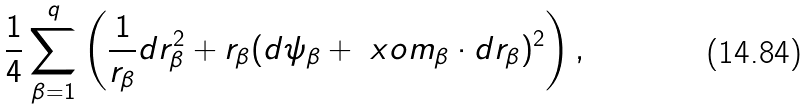<formula> <loc_0><loc_0><loc_500><loc_500>\frac { 1 } { 4 } \sum _ { \beta = 1 } ^ { q } \left ( \frac { 1 } { r _ { \beta } } d { r } _ { \beta } ^ { 2 } + r _ { \beta } ( d \psi _ { \beta } + { \ x o m } _ { \beta } \cdot d { r } _ { \beta } ) ^ { 2 } \right ) ,</formula> 